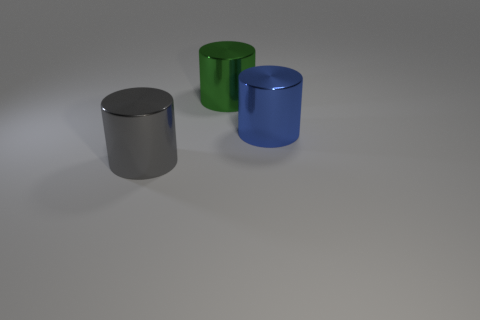There is a big cylinder that is in front of the blue object; is its color the same as the large thing behind the big blue cylinder?
Offer a terse response. No. What is the material of the big thing that is in front of the green thing and on the left side of the blue thing?
Keep it short and to the point. Metal. Is there a gray shiny object?
Make the answer very short. Yes. Is the shape of the green shiny object the same as the thing that is on the left side of the green metal cylinder?
Provide a short and direct response. Yes. What is the material of the cylinder in front of the object that is on the right side of the green metallic thing?
Give a very brief answer. Metal. There is a large shiny object on the right side of the green metal cylinder; is it the same shape as the large object behind the blue shiny object?
Provide a short and direct response. Yes. Is there anything else that is made of the same material as the blue object?
Your response must be concise. Yes. What is the material of the blue cylinder?
Keep it short and to the point. Metal. What is the material of the large cylinder that is in front of the large blue metallic cylinder?
Give a very brief answer. Metal. There is a blue cylinder that is made of the same material as the green thing; what size is it?
Keep it short and to the point. Large. 